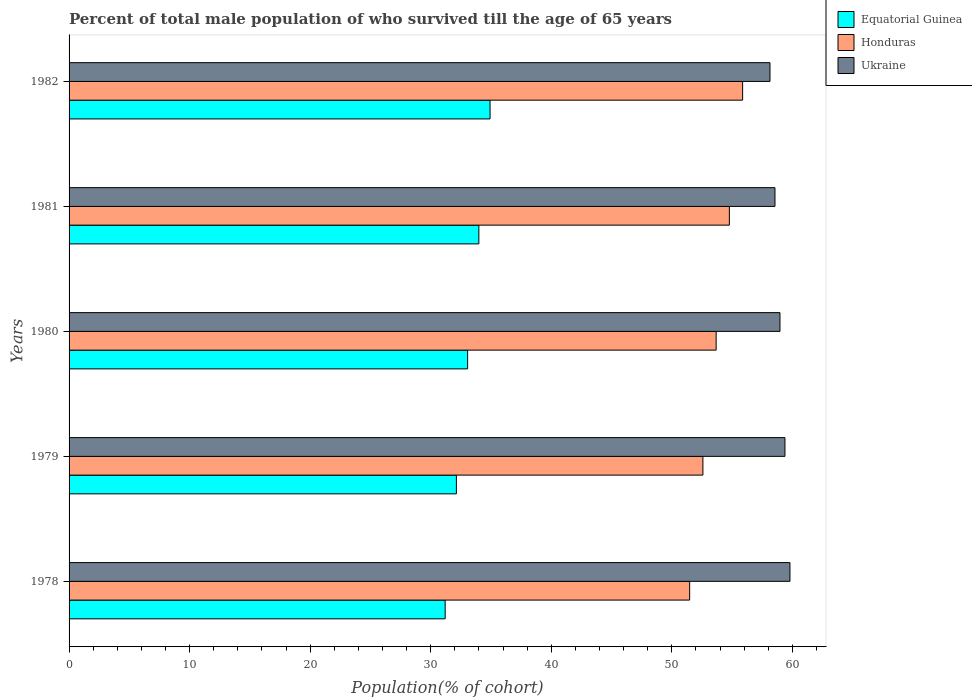Are the number of bars per tick equal to the number of legend labels?
Offer a very short reply. Yes. Are the number of bars on each tick of the Y-axis equal?
Offer a very short reply. Yes. In how many cases, is the number of bars for a given year not equal to the number of legend labels?
Offer a very short reply. 0. What is the percentage of total male population who survived till the age of 65 years in Equatorial Guinea in 1979?
Make the answer very short. 32.13. Across all years, what is the maximum percentage of total male population who survived till the age of 65 years in Ukraine?
Your answer should be compact. 59.8. Across all years, what is the minimum percentage of total male population who survived till the age of 65 years in Honduras?
Your answer should be compact. 51.48. In which year was the percentage of total male population who survived till the age of 65 years in Ukraine maximum?
Make the answer very short. 1978. In which year was the percentage of total male population who survived till the age of 65 years in Honduras minimum?
Make the answer very short. 1978. What is the total percentage of total male population who survived till the age of 65 years in Equatorial Guinea in the graph?
Your answer should be compact. 165.31. What is the difference between the percentage of total male population who survived till the age of 65 years in Honduras in 1979 and that in 1980?
Make the answer very short. -1.1. What is the difference between the percentage of total male population who survived till the age of 65 years in Equatorial Guinea in 1981 and the percentage of total male population who survived till the age of 65 years in Ukraine in 1982?
Provide a short and direct response. -24.15. What is the average percentage of total male population who survived till the age of 65 years in Honduras per year?
Your answer should be compact. 53.68. In the year 1981, what is the difference between the percentage of total male population who survived till the age of 65 years in Honduras and percentage of total male population who survived till the age of 65 years in Equatorial Guinea?
Your answer should be very brief. 20.78. In how many years, is the percentage of total male population who survived till the age of 65 years in Honduras greater than 44 %?
Offer a terse response. 5. What is the ratio of the percentage of total male population who survived till the age of 65 years in Ukraine in 1978 to that in 1981?
Your answer should be very brief. 1.02. What is the difference between the highest and the second highest percentage of total male population who survived till the age of 65 years in Ukraine?
Keep it short and to the point. 0.41. What is the difference between the highest and the lowest percentage of total male population who survived till the age of 65 years in Equatorial Guinea?
Your answer should be very brief. 3.72. What does the 2nd bar from the top in 1978 represents?
Provide a succinct answer. Honduras. What does the 2nd bar from the bottom in 1979 represents?
Ensure brevity in your answer.  Honduras. Are all the bars in the graph horizontal?
Ensure brevity in your answer.  Yes. How many years are there in the graph?
Your answer should be compact. 5. What is the difference between two consecutive major ticks on the X-axis?
Your answer should be compact. 10. Does the graph contain any zero values?
Ensure brevity in your answer.  No. Where does the legend appear in the graph?
Ensure brevity in your answer.  Top right. How many legend labels are there?
Your answer should be very brief. 3. How are the legend labels stacked?
Give a very brief answer. Vertical. What is the title of the graph?
Provide a short and direct response. Percent of total male population of who survived till the age of 65 years. Does "World" appear as one of the legend labels in the graph?
Your response must be concise. No. What is the label or title of the X-axis?
Give a very brief answer. Population(% of cohort). What is the label or title of the Y-axis?
Your answer should be very brief. Years. What is the Population(% of cohort) of Equatorial Guinea in 1978?
Offer a very short reply. 31.2. What is the Population(% of cohort) of Honduras in 1978?
Keep it short and to the point. 51.48. What is the Population(% of cohort) of Ukraine in 1978?
Offer a very short reply. 59.8. What is the Population(% of cohort) of Equatorial Guinea in 1979?
Ensure brevity in your answer.  32.13. What is the Population(% of cohort) in Honduras in 1979?
Provide a short and direct response. 52.58. What is the Population(% of cohort) in Ukraine in 1979?
Offer a very short reply. 59.39. What is the Population(% of cohort) of Equatorial Guinea in 1980?
Offer a very short reply. 33.06. What is the Population(% of cohort) of Honduras in 1980?
Give a very brief answer. 53.68. What is the Population(% of cohort) in Ukraine in 1980?
Ensure brevity in your answer.  58.97. What is the Population(% of cohort) of Equatorial Guinea in 1981?
Provide a short and direct response. 33.99. What is the Population(% of cohort) in Honduras in 1981?
Your answer should be compact. 54.78. What is the Population(% of cohort) in Ukraine in 1981?
Offer a very short reply. 58.56. What is the Population(% of cohort) in Equatorial Guinea in 1982?
Offer a very short reply. 34.92. What is the Population(% of cohort) of Honduras in 1982?
Make the answer very short. 55.88. What is the Population(% of cohort) in Ukraine in 1982?
Give a very brief answer. 58.14. Across all years, what is the maximum Population(% of cohort) of Equatorial Guinea?
Your answer should be compact. 34.92. Across all years, what is the maximum Population(% of cohort) of Honduras?
Make the answer very short. 55.88. Across all years, what is the maximum Population(% of cohort) in Ukraine?
Make the answer very short. 59.8. Across all years, what is the minimum Population(% of cohort) in Equatorial Guinea?
Give a very brief answer. 31.2. Across all years, what is the minimum Population(% of cohort) of Honduras?
Your answer should be very brief. 51.48. Across all years, what is the minimum Population(% of cohort) of Ukraine?
Give a very brief answer. 58.14. What is the total Population(% of cohort) in Equatorial Guinea in the graph?
Ensure brevity in your answer.  165.31. What is the total Population(% of cohort) of Honduras in the graph?
Offer a very short reply. 268.39. What is the total Population(% of cohort) of Ukraine in the graph?
Ensure brevity in your answer.  294.86. What is the difference between the Population(% of cohort) in Equatorial Guinea in 1978 and that in 1979?
Ensure brevity in your answer.  -0.93. What is the difference between the Population(% of cohort) of Honduras in 1978 and that in 1979?
Offer a terse response. -1.1. What is the difference between the Population(% of cohort) in Ukraine in 1978 and that in 1979?
Offer a very short reply. 0.41. What is the difference between the Population(% of cohort) of Equatorial Guinea in 1978 and that in 1980?
Provide a succinct answer. -1.86. What is the difference between the Population(% of cohort) of Honduras in 1978 and that in 1980?
Provide a short and direct response. -2.2. What is the difference between the Population(% of cohort) in Ukraine in 1978 and that in 1980?
Offer a very short reply. 0.83. What is the difference between the Population(% of cohort) of Equatorial Guinea in 1978 and that in 1981?
Your response must be concise. -2.79. What is the difference between the Population(% of cohort) in Honduras in 1978 and that in 1981?
Provide a short and direct response. -3.3. What is the difference between the Population(% of cohort) of Ukraine in 1978 and that in 1981?
Make the answer very short. 1.24. What is the difference between the Population(% of cohort) in Equatorial Guinea in 1978 and that in 1982?
Provide a short and direct response. -3.72. What is the difference between the Population(% of cohort) of Honduras in 1978 and that in 1982?
Keep it short and to the point. -4.39. What is the difference between the Population(% of cohort) in Ukraine in 1978 and that in 1982?
Make the answer very short. 1.66. What is the difference between the Population(% of cohort) of Equatorial Guinea in 1979 and that in 1980?
Provide a succinct answer. -0.93. What is the difference between the Population(% of cohort) of Honduras in 1979 and that in 1980?
Ensure brevity in your answer.  -1.1. What is the difference between the Population(% of cohort) in Ukraine in 1979 and that in 1980?
Make the answer very short. 0.41. What is the difference between the Population(% of cohort) in Equatorial Guinea in 1979 and that in 1981?
Give a very brief answer. -1.86. What is the difference between the Population(% of cohort) in Honduras in 1979 and that in 1981?
Offer a terse response. -2.2. What is the difference between the Population(% of cohort) of Ukraine in 1979 and that in 1981?
Offer a terse response. 0.83. What is the difference between the Population(% of cohort) in Equatorial Guinea in 1979 and that in 1982?
Make the answer very short. -2.79. What is the difference between the Population(% of cohort) in Honduras in 1979 and that in 1982?
Provide a succinct answer. -3.3. What is the difference between the Population(% of cohort) in Ukraine in 1979 and that in 1982?
Offer a very short reply. 1.24. What is the difference between the Population(% of cohort) in Equatorial Guinea in 1980 and that in 1981?
Your response must be concise. -0.93. What is the difference between the Population(% of cohort) of Honduras in 1980 and that in 1981?
Offer a terse response. -1.1. What is the difference between the Population(% of cohort) of Ukraine in 1980 and that in 1981?
Make the answer very short. 0.41. What is the difference between the Population(% of cohort) of Equatorial Guinea in 1980 and that in 1982?
Your answer should be compact. -1.86. What is the difference between the Population(% of cohort) of Honduras in 1980 and that in 1982?
Offer a terse response. -2.2. What is the difference between the Population(% of cohort) in Ukraine in 1980 and that in 1982?
Your answer should be very brief. 0.83. What is the difference between the Population(% of cohort) of Equatorial Guinea in 1981 and that in 1982?
Make the answer very short. -0.93. What is the difference between the Population(% of cohort) in Honduras in 1981 and that in 1982?
Your answer should be very brief. -1.1. What is the difference between the Population(% of cohort) of Ukraine in 1981 and that in 1982?
Offer a terse response. 0.41. What is the difference between the Population(% of cohort) of Equatorial Guinea in 1978 and the Population(% of cohort) of Honduras in 1979?
Keep it short and to the point. -21.38. What is the difference between the Population(% of cohort) in Equatorial Guinea in 1978 and the Population(% of cohort) in Ukraine in 1979?
Keep it short and to the point. -28.19. What is the difference between the Population(% of cohort) of Honduras in 1978 and the Population(% of cohort) of Ukraine in 1979?
Give a very brief answer. -7.91. What is the difference between the Population(% of cohort) in Equatorial Guinea in 1978 and the Population(% of cohort) in Honduras in 1980?
Provide a succinct answer. -22.48. What is the difference between the Population(% of cohort) of Equatorial Guinea in 1978 and the Population(% of cohort) of Ukraine in 1980?
Provide a short and direct response. -27.77. What is the difference between the Population(% of cohort) of Honduras in 1978 and the Population(% of cohort) of Ukraine in 1980?
Your response must be concise. -7.49. What is the difference between the Population(% of cohort) of Equatorial Guinea in 1978 and the Population(% of cohort) of Honduras in 1981?
Give a very brief answer. -23.58. What is the difference between the Population(% of cohort) of Equatorial Guinea in 1978 and the Population(% of cohort) of Ukraine in 1981?
Provide a short and direct response. -27.36. What is the difference between the Population(% of cohort) in Honduras in 1978 and the Population(% of cohort) in Ukraine in 1981?
Provide a short and direct response. -7.08. What is the difference between the Population(% of cohort) of Equatorial Guinea in 1978 and the Population(% of cohort) of Honduras in 1982?
Make the answer very short. -24.67. What is the difference between the Population(% of cohort) in Equatorial Guinea in 1978 and the Population(% of cohort) in Ukraine in 1982?
Your answer should be compact. -26.94. What is the difference between the Population(% of cohort) of Honduras in 1978 and the Population(% of cohort) of Ukraine in 1982?
Give a very brief answer. -6.66. What is the difference between the Population(% of cohort) in Equatorial Guinea in 1979 and the Population(% of cohort) in Honduras in 1980?
Keep it short and to the point. -21.55. What is the difference between the Population(% of cohort) of Equatorial Guinea in 1979 and the Population(% of cohort) of Ukraine in 1980?
Make the answer very short. -26.84. What is the difference between the Population(% of cohort) of Honduras in 1979 and the Population(% of cohort) of Ukraine in 1980?
Your answer should be very brief. -6.39. What is the difference between the Population(% of cohort) of Equatorial Guinea in 1979 and the Population(% of cohort) of Honduras in 1981?
Offer a very short reply. -22.65. What is the difference between the Population(% of cohort) of Equatorial Guinea in 1979 and the Population(% of cohort) of Ukraine in 1981?
Keep it short and to the point. -26.43. What is the difference between the Population(% of cohort) of Honduras in 1979 and the Population(% of cohort) of Ukraine in 1981?
Your response must be concise. -5.98. What is the difference between the Population(% of cohort) of Equatorial Guinea in 1979 and the Population(% of cohort) of Honduras in 1982?
Provide a short and direct response. -23.74. What is the difference between the Population(% of cohort) of Equatorial Guinea in 1979 and the Population(% of cohort) of Ukraine in 1982?
Offer a terse response. -26.01. What is the difference between the Population(% of cohort) in Honduras in 1979 and the Population(% of cohort) in Ukraine in 1982?
Make the answer very short. -5.56. What is the difference between the Population(% of cohort) of Equatorial Guinea in 1980 and the Population(% of cohort) of Honduras in 1981?
Offer a terse response. -21.71. What is the difference between the Population(% of cohort) of Equatorial Guinea in 1980 and the Population(% of cohort) of Ukraine in 1981?
Make the answer very short. -25.5. What is the difference between the Population(% of cohort) in Honduras in 1980 and the Population(% of cohort) in Ukraine in 1981?
Ensure brevity in your answer.  -4.88. What is the difference between the Population(% of cohort) of Equatorial Guinea in 1980 and the Population(% of cohort) of Honduras in 1982?
Your answer should be compact. -22.81. What is the difference between the Population(% of cohort) in Equatorial Guinea in 1980 and the Population(% of cohort) in Ukraine in 1982?
Give a very brief answer. -25.08. What is the difference between the Population(% of cohort) of Honduras in 1980 and the Population(% of cohort) of Ukraine in 1982?
Your answer should be very brief. -4.47. What is the difference between the Population(% of cohort) of Equatorial Guinea in 1981 and the Population(% of cohort) of Honduras in 1982?
Ensure brevity in your answer.  -21.88. What is the difference between the Population(% of cohort) in Equatorial Guinea in 1981 and the Population(% of cohort) in Ukraine in 1982?
Give a very brief answer. -24.15. What is the difference between the Population(% of cohort) of Honduras in 1981 and the Population(% of cohort) of Ukraine in 1982?
Give a very brief answer. -3.37. What is the average Population(% of cohort) of Equatorial Guinea per year?
Your response must be concise. 33.06. What is the average Population(% of cohort) in Honduras per year?
Offer a very short reply. 53.68. What is the average Population(% of cohort) of Ukraine per year?
Keep it short and to the point. 58.97. In the year 1978, what is the difference between the Population(% of cohort) of Equatorial Guinea and Population(% of cohort) of Honduras?
Your answer should be very brief. -20.28. In the year 1978, what is the difference between the Population(% of cohort) of Equatorial Guinea and Population(% of cohort) of Ukraine?
Your response must be concise. -28.6. In the year 1978, what is the difference between the Population(% of cohort) of Honduras and Population(% of cohort) of Ukraine?
Make the answer very short. -8.32. In the year 1979, what is the difference between the Population(% of cohort) in Equatorial Guinea and Population(% of cohort) in Honduras?
Offer a very short reply. -20.45. In the year 1979, what is the difference between the Population(% of cohort) of Equatorial Guinea and Population(% of cohort) of Ukraine?
Offer a terse response. -27.26. In the year 1979, what is the difference between the Population(% of cohort) of Honduras and Population(% of cohort) of Ukraine?
Make the answer very short. -6.81. In the year 1980, what is the difference between the Population(% of cohort) of Equatorial Guinea and Population(% of cohort) of Honduras?
Ensure brevity in your answer.  -20.62. In the year 1980, what is the difference between the Population(% of cohort) of Equatorial Guinea and Population(% of cohort) of Ukraine?
Offer a terse response. -25.91. In the year 1980, what is the difference between the Population(% of cohort) in Honduras and Population(% of cohort) in Ukraine?
Your answer should be very brief. -5.29. In the year 1981, what is the difference between the Population(% of cohort) of Equatorial Guinea and Population(% of cohort) of Honduras?
Make the answer very short. -20.78. In the year 1981, what is the difference between the Population(% of cohort) in Equatorial Guinea and Population(% of cohort) in Ukraine?
Provide a short and direct response. -24.57. In the year 1981, what is the difference between the Population(% of cohort) of Honduras and Population(% of cohort) of Ukraine?
Ensure brevity in your answer.  -3.78. In the year 1982, what is the difference between the Population(% of cohort) in Equatorial Guinea and Population(% of cohort) in Honduras?
Your answer should be compact. -20.95. In the year 1982, what is the difference between the Population(% of cohort) of Equatorial Guinea and Population(% of cohort) of Ukraine?
Your response must be concise. -23.22. In the year 1982, what is the difference between the Population(% of cohort) in Honduras and Population(% of cohort) in Ukraine?
Give a very brief answer. -2.27. What is the ratio of the Population(% of cohort) in Equatorial Guinea in 1978 to that in 1979?
Make the answer very short. 0.97. What is the ratio of the Population(% of cohort) in Honduras in 1978 to that in 1979?
Provide a short and direct response. 0.98. What is the ratio of the Population(% of cohort) of Ukraine in 1978 to that in 1979?
Your answer should be very brief. 1.01. What is the ratio of the Population(% of cohort) of Equatorial Guinea in 1978 to that in 1980?
Provide a short and direct response. 0.94. What is the ratio of the Population(% of cohort) of Honduras in 1978 to that in 1980?
Give a very brief answer. 0.96. What is the ratio of the Population(% of cohort) of Equatorial Guinea in 1978 to that in 1981?
Offer a terse response. 0.92. What is the ratio of the Population(% of cohort) in Honduras in 1978 to that in 1981?
Make the answer very short. 0.94. What is the ratio of the Population(% of cohort) in Ukraine in 1978 to that in 1981?
Keep it short and to the point. 1.02. What is the ratio of the Population(% of cohort) of Equatorial Guinea in 1978 to that in 1982?
Your response must be concise. 0.89. What is the ratio of the Population(% of cohort) in Honduras in 1978 to that in 1982?
Your answer should be very brief. 0.92. What is the ratio of the Population(% of cohort) of Ukraine in 1978 to that in 1982?
Give a very brief answer. 1.03. What is the ratio of the Population(% of cohort) of Equatorial Guinea in 1979 to that in 1980?
Ensure brevity in your answer.  0.97. What is the ratio of the Population(% of cohort) of Honduras in 1979 to that in 1980?
Keep it short and to the point. 0.98. What is the ratio of the Population(% of cohort) in Equatorial Guinea in 1979 to that in 1981?
Keep it short and to the point. 0.95. What is the ratio of the Population(% of cohort) in Honduras in 1979 to that in 1981?
Make the answer very short. 0.96. What is the ratio of the Population(% of cohort) of Ukraine in 1979 to that in 1981?
Offer a terse response. 1.01. What is the ratio of the Population(% of cohort) in Honduras in 1979 to that in 1982?
Provide a succinct answer. 0.94. What is the ratio of the Population(% of cohort) of Ukraine in 1979 to that in 1982?
Provide a short and direct response. 1.02. What is the ratio of the Population(% of cohort) in Equatorial Guinea in 1980 to that in 1981?
Give a very brief answer. 0.97. What is the ratio of the Population(% of cohort) in Honduras in 1980 to that in 1981?
Provide a short and direct response. 0.98. What is the ratio of the Population(% of cohort) of Ukraine in 1980 to that in 1981?
Your response must be concise. 1.01. What is the ratio of the Population(% of cohort) in Equatorial Guinea in 1980 to that in 1982?
Provide a short and direct response. 0.95. What is the ratio of the Population(% of cohort) of Honduras in 1980 to that in 1982?
Keep it short and to the point. 0.96. What is the ratio of the Population(% of cohort) in Ukraine in 1980 to that in 1982?
Ensure brevity in your answer.  1.01. What is the ratio of the Population(% of cohort) in Equatorial Guinea in 1981 to that in 1982?
Ensure brevity in your answer.  0.97. What is the ratio of the Population(% of cohort) of Honduras in 1981 to that in 1982?
Keep it short and to the point. 0.98. What is the ratio of the Population(% of cohort) of Ukraine in 1981 to that in 1982?
Offer a terse response. 1.01. What is the difference between the highest and the second highest Population(% of cohort) in Equatorial Guinea?
Give a very brief answer. 0.93. What is the difference between the highest and the second highest Population(% of cohort) in Honduras?
Provide a succinct answer. 1.1. What is the difference between the highest and the second highest Population(% of cohort) in Ukraine?
Give a very brief answer. 0.41. What is the difference between the highest and the lowest Population(% of cohort) of Equatorial Guinea?
Offer a very short reply. 3.72. What is the difference between the highest and the lowest Population(% of cohort) of Honduras?
Provide a short and direct response. 4.39. What is the difference between the highest and the lowest Population(% of cohort) in Ukraine?
Offer a very short reply. 1.66. 